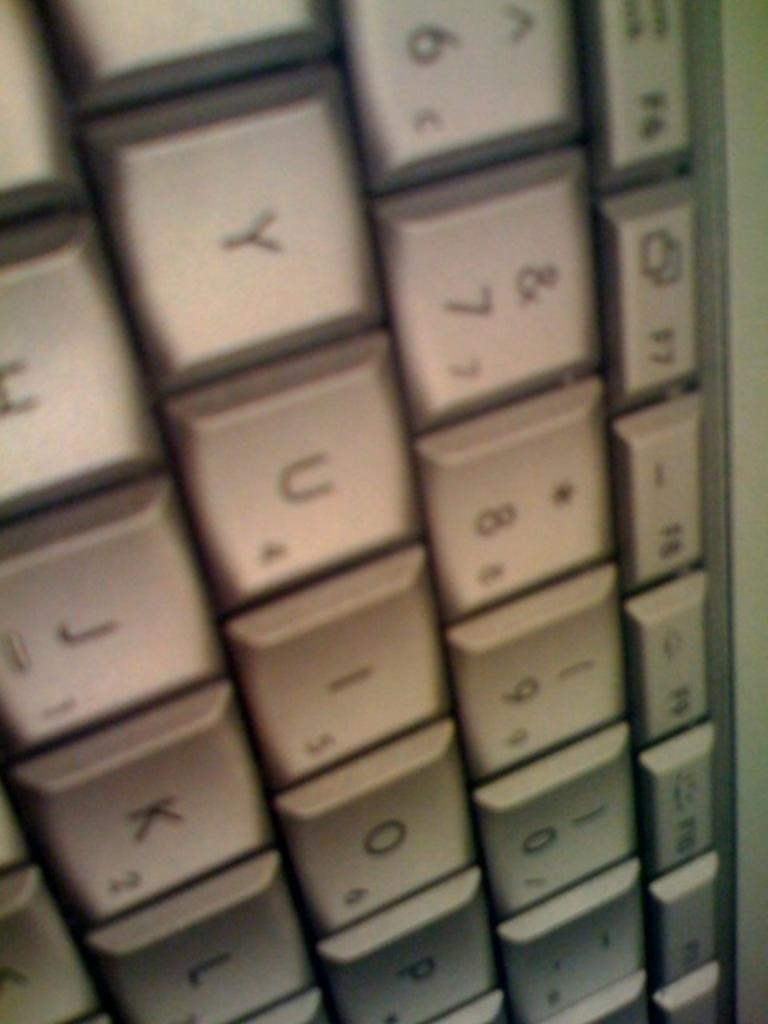<image>
Render a clear and concise summary of the photo. the number 7 that is on a keyboard 